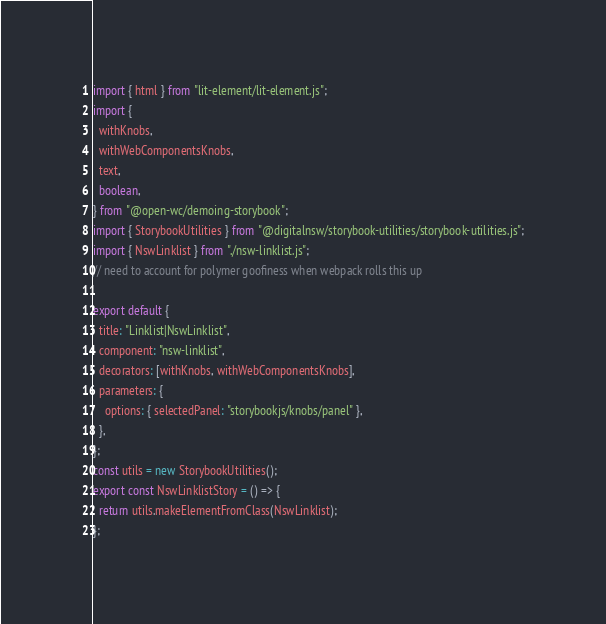Convert code to text. <code><loc_0><loc_0><loc_500><loc_500><_JavaScript_>import { html } from "lit-element/lit-element.js";
import {
  withKnobs,
  withWebComponentsKnobs,
  text,
  boolean,
} from "@open-wc/demoing-storybook";
import { StorybookUtilities } from "@digitalnsw/storybook-utilities/storybook-utilities.js";
import { NswLinklist } from "./nsw-linklist.js";
// need to account for polymer goofiness when webpack rolls this up

export default {
  title: "Linklist|NswLinklist",
  component: "nsw-linklist",
  decorators: [withKnobs, withWebComponentsKnobs],
  parameters: {
    options: { selectedPanel: "storybookjs/knobs/panel" },
  },
};
const utils = new StorybookUtilities();
export const NswLinklistStory = () => {
  return utils.makeElementFromClass(NswLinklist);
};
</code> 